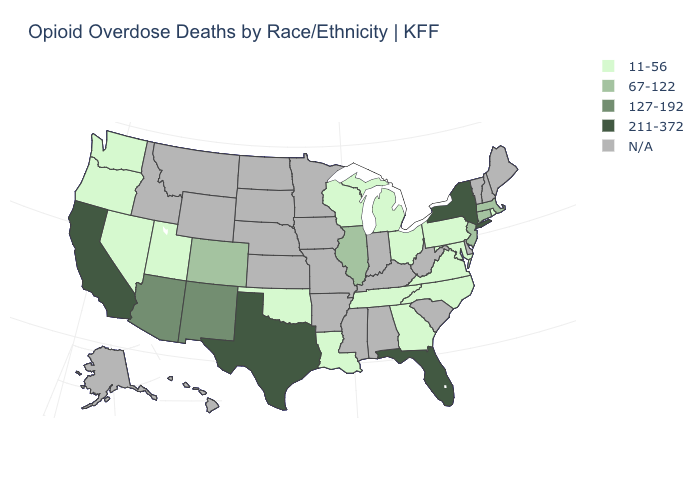Name the states that have a value in the range 11-56?
Answer briefly. Georgia, Louisiana, Maryland, Michigan, Nevada, North Carolina, Ohio, Oklahoma, Oregon, Pennsylvania, Rhode Island, Tennessee, Utah, Virginia, Washington, Wisconsin. Is the legend a continuous bar?
Quick response, please. No. Among the states that border Michigan , which have the lowest value?
Write a very short answer. Ohio, Wisconsin. Which states have the lowest value in the USA?
Quick response, please. Georgia, Louisiana, Maryland, Michigan, Nevada, North Carolina, Ohio, Oklahoma, Oregon, Pennsylvania, Rhode Island, Tennessee, Utah, Virginia, Washington, Wisconsin. What is the lowest value in the South?
Keep it brief. 11-56. What is the value of Maine?
Short answer required. N/A. What is the value of Georgia?
Answer briefly. 11-56. Which states have the lowest value in the South?
Write a very short answer. Georgia, Louisiana, Maryland, North Carolina, Oklahoma, Tennessee, Virginia. What is the lowest value in states that border New York?
Answer briefly. 11-56. Name the states that have a value in the range 11-56?
Be succinct. Georgia, Louisiana, Maryland, Michigan, Nevada, North Carolina, Ohio, Oklahoma, Oregon, Pennsylvania, Rhode Island, Tennessee, Utah, Virginia, Washington, Wisconsin. What is the highest value in the USA?
Answer briefly. 211-372. Name the states that have a value in the range 67-122?
Concise answer only. Colorado, Connecticut, Illinois, Massachusetts, New Jersey. 